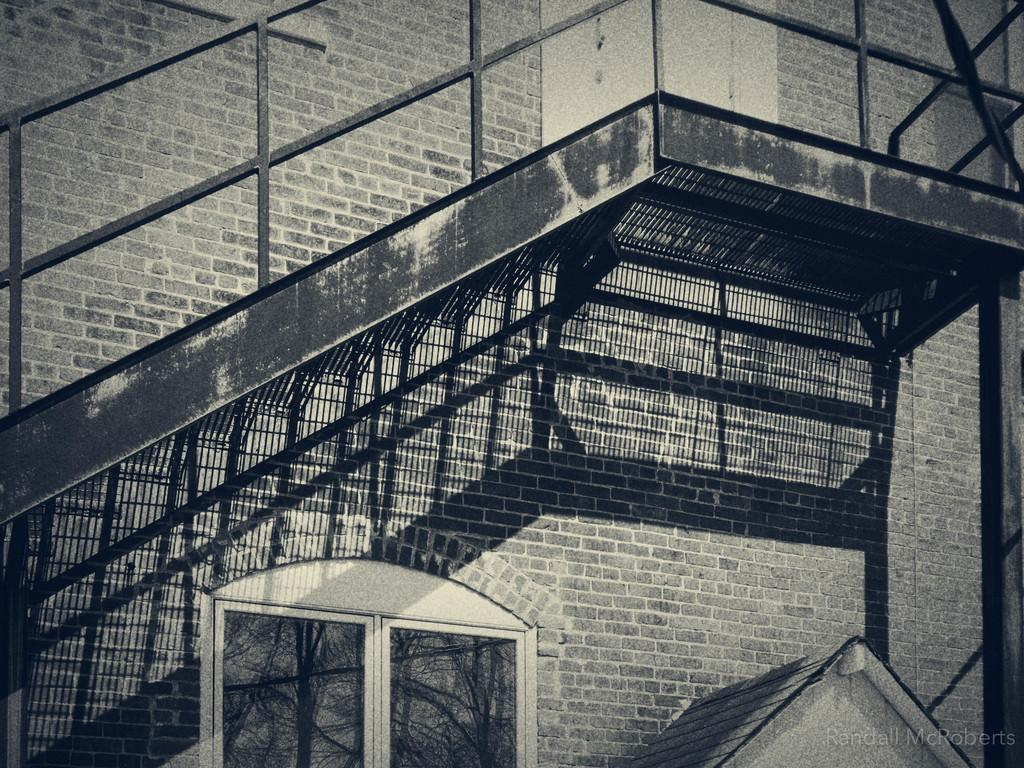What is the color scheme of the image? The image is black and white. What type of structure can be seen in the image? There is a building in the image. What architectural feature is present in front of the building? There are stairs in front of the building. What thought is the building having in the image? Buildings do not have thoughts, as they are inanimate objects. 